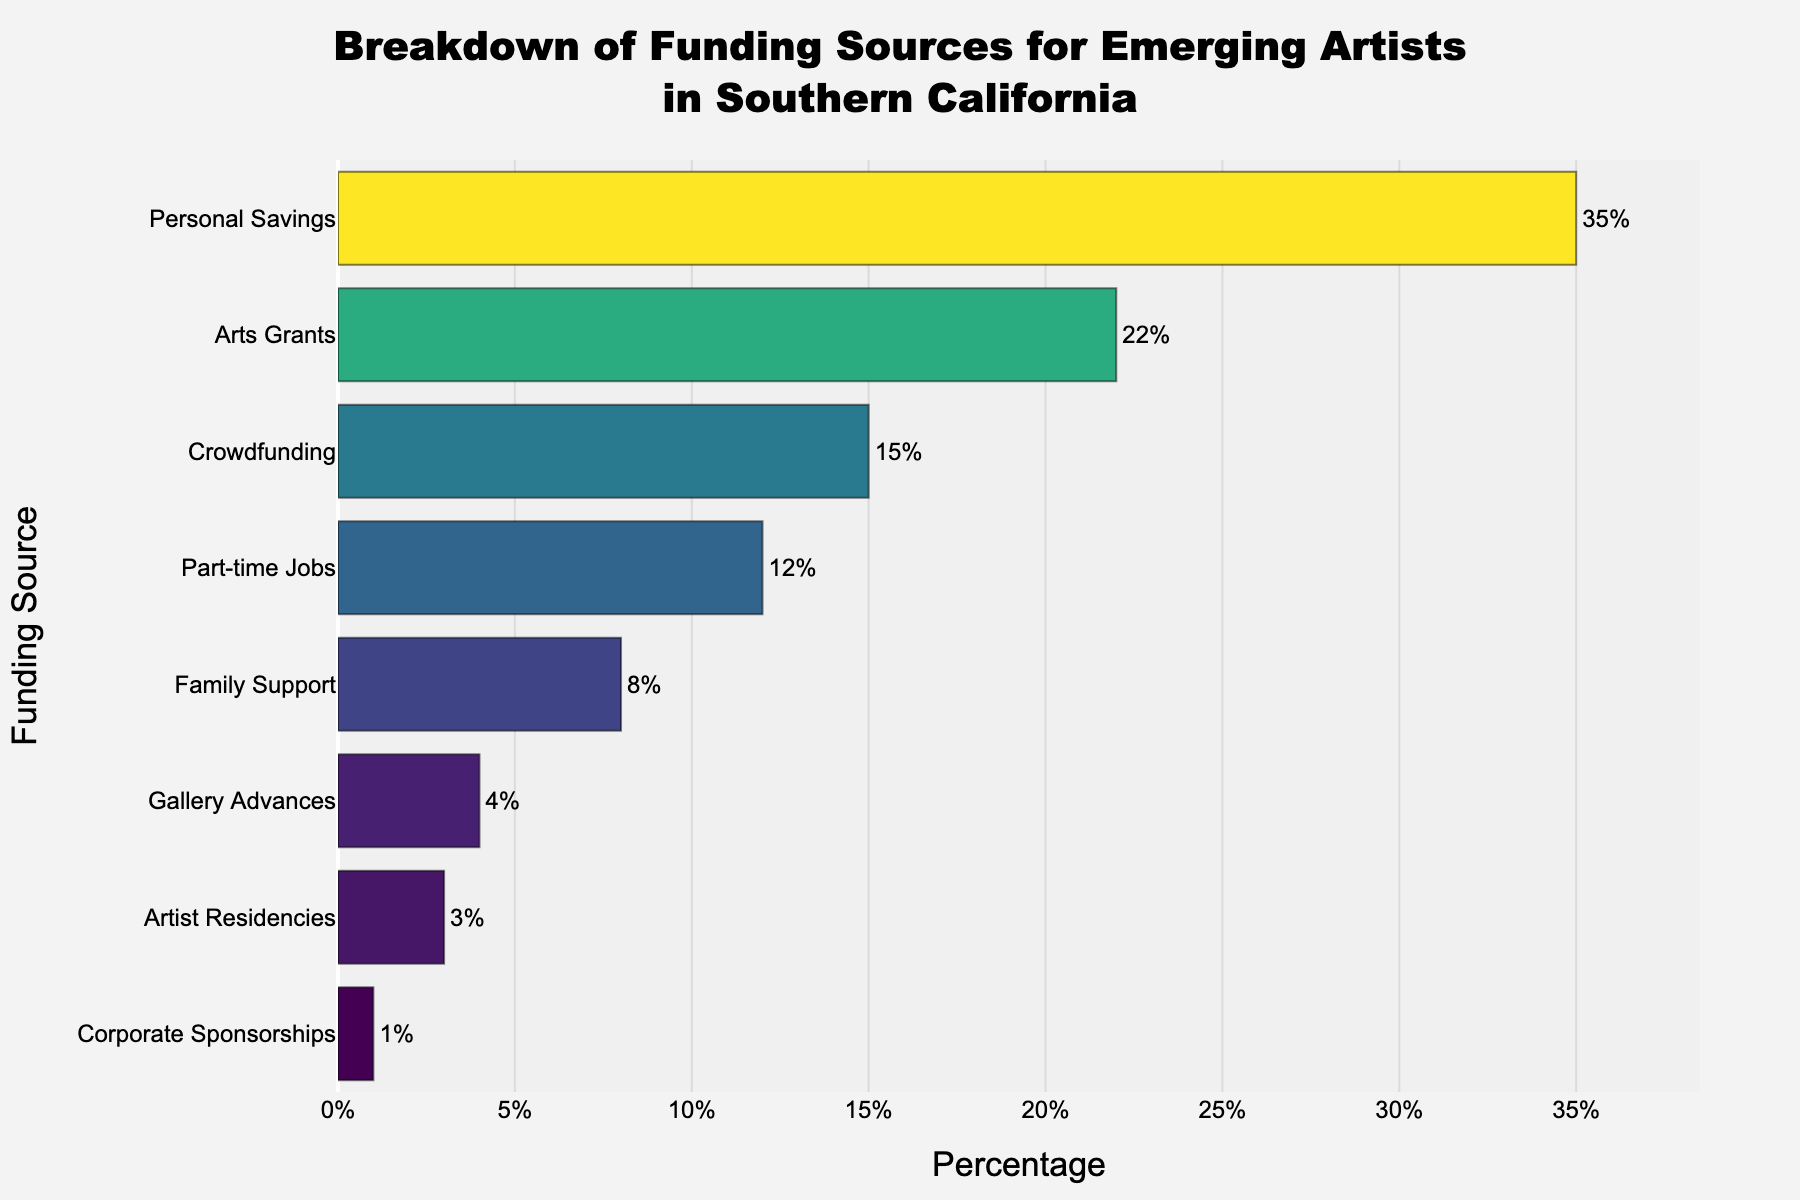What's the highest percentage funding source for emerging artists in Southern California? The figure shows a bar chart with various funding sources for emerging artists and their respective percentages. By observing the length of the bars, the longest bar corresponds to "Personal Savings" at 35%.
Answer: Personal Savings What's the sum of the percentages from Arts Grants and Crowdfunding? To find the sum, look at the "Arts Grants" and "Crowdfunding" bars. Arts Grants is 22% and Crowdfunding is 15%. Adding these together gives 22% + 15% = 37%.
Answer: 37% Which funding source has a higher percentage: Family Support or Part-time Jobs? By comparing the lengths of the bars for "Family Support" and "Part-time Jobs," Part-time Jobs has a longer bar at 12% compared to Family Support at 8%.
Answer: Part-time Jobs What's the mean percentage of the funding sources that are below 10%? To find the mean of funding sources below 10%, identify "Family Support" (8%), "Gallery Advances" (4%), "Artist Residencies" (3%), and "Corporate Sponsorships" (1%). Add these: 8% + 4% + 3% + 1% = 16%, then divide by the number of sources (4). The mean is 16% / 4 = 4%.
Answer: 4% Are there more funding sources at or above 10% or below 10%? Count the funding sources listed on the y-axis at or above 10%: "Personal Savings", "Arts Grants", "Crowdfunding", and "Part-time Jobs" (4 sources). For below 10%, count "Family Support", "Gallery Advances", "Artist Residencies", and "Corporate Sponsorships" (4 sources). Both categories have an equal number.
Answer: Equal Which funding source has the least representation? The shortest bar in the figure corresponds to "Corporate Sponsorships", which has a percentage of 1%.
Answer: Corporate Sponsorships What is the difference in percentage points between Personal Savings and Corporate Sponsorships? Personal Savings is 35%, and Corporate Sponsorships is 1%. The difference is 35% - 1% = 34%.
Answer: 34% Which funding source represents approximately one-tenth of the total percentage represented by Personal Savings? Personal Savings is 35%. One-tenth of 35% is 35% / 10 = 3.5%. "Artist Residencies" is closest at 3%.
Answer: Artist Residencies 